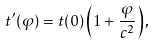Convert formula to latex. <formula><loc_0><loc_0><loc_500><loc_500>t ^ { \prime } ( \varphi ) = t ( 0 ) \left ( 1 + \frac { \varphi } { c ^ { 2 } } \right ) ,</formula> 